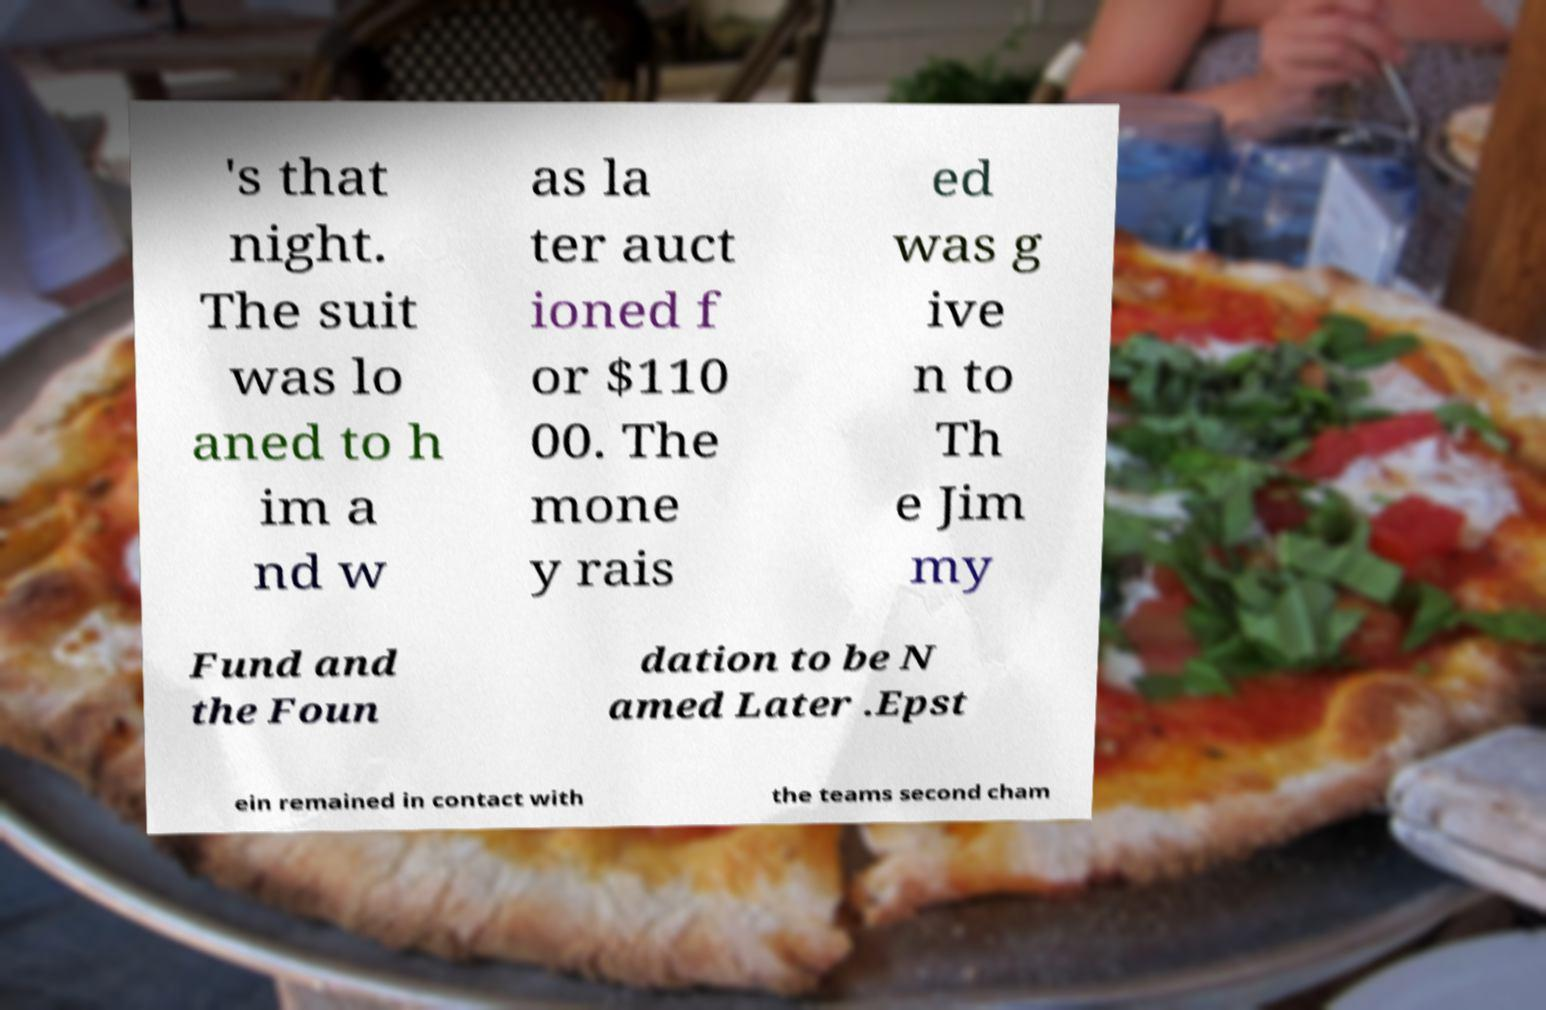For documentation purposes, I need the text within this image transcribed. Could you provide that? 's that night. The suit was lo aned to h im a nd w as la ter auct ioned f or $110 00. The mone y rais ed was g ive n to Th e Jim my Fund and the Foun dation to be N amed Later .Epst ein remained in contact with the teams second cham 